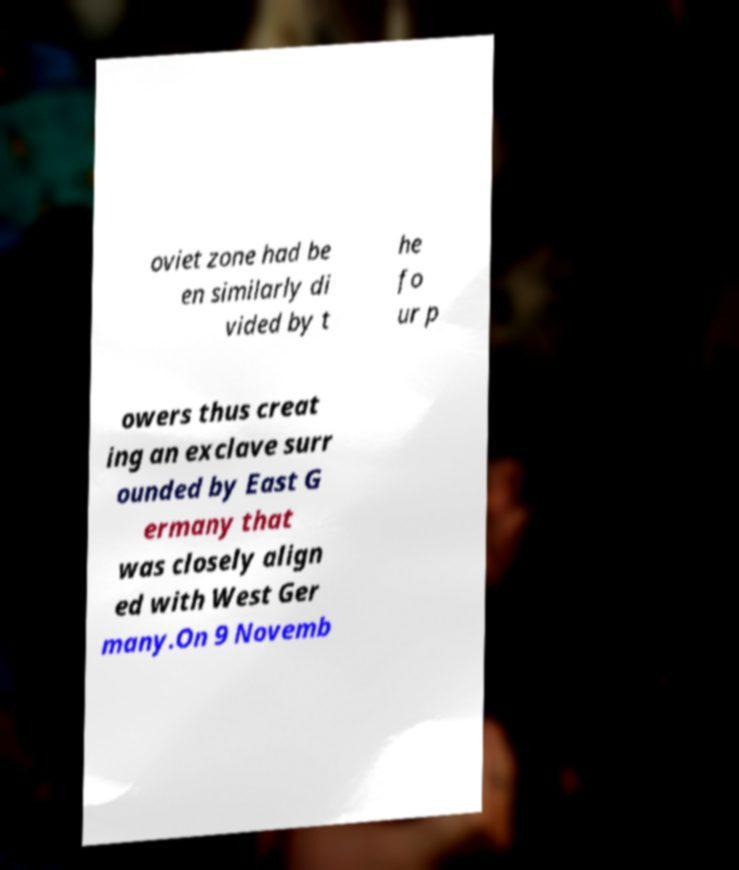Can you read and provide the text displayed in the image?This photo seems to have some interesting text. Can you extract and type it out for me? oviet zone had be en similarly di vided by t he fo ur p owers thus creat ing an exclave surr ounded by East G ermany that was closely align ed with West Ger many.On 9 Novemb 